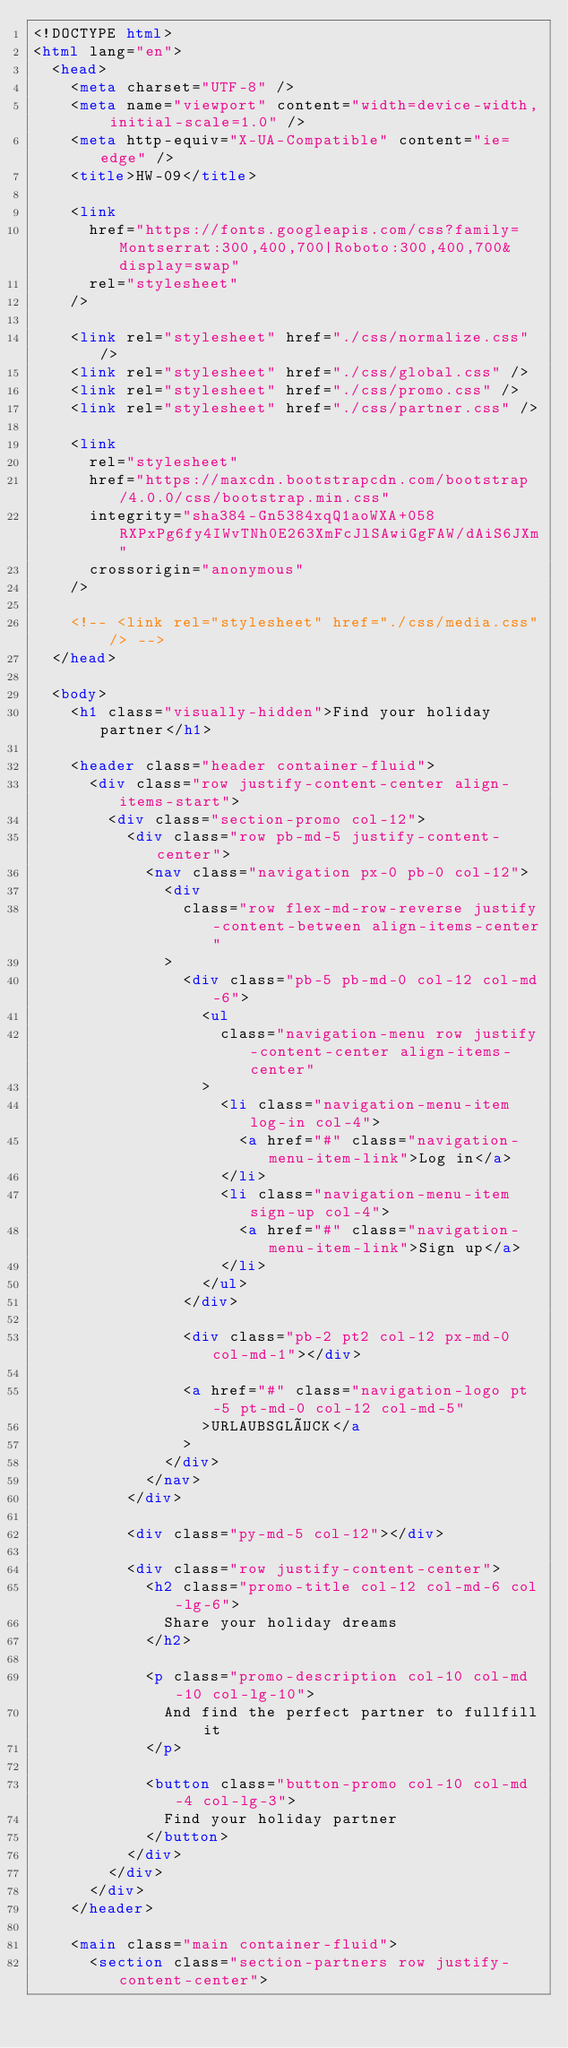Convert code to text. <code><loc_0><loc_0><loc_500><loc_500><_HTML_><!DOCTYPE html>
<html lang="en">
  <head>
    <meta charset="UTF-8" />
    <meta name="viewport" content="width=device-width, initial-scale=1.0" />
    <meta http-equiv="X-UA-Compatible" content="ie=edge" />
    <title>HW-09</title>

    <link
      href="https://fonts.googleapis.com/css?family=Montserrat:300,400,700|Roboto:300,400,700&display=swap"
      rel="stylesheet"
    />

    <link rel="stylesheet" href="./css/normalize.css" />
    <link rel="stylesheet" href="./css/global.css" />
    <link rel="stylesheet" href="./css/promo.css" />
    <link rel="stylesheet" href="./css/partner.css" />

    <link
      rel="stylesheet"
      href="https://maxcdn.bootstrapcdn.com/bootstrap/4.0.0/css/bootstrap.min.css"
      integrity="sha384-Gn5384xqQ1aoWXA+058RXPxPg6fy4IWvTNh0E263XmFcJlSAwiGgFAW/dAiS6JXm"
      crossorigin="anonymous"
    />

    <!-- <link rel="stylesheet" href="./css/media.css" /> -->
  </head>

  <body>
    <h1 class="visually-hidden">Find your holiday partner</h1>

    <header class="header container-fluid">
      <div class="row justify-content-center align-items-start">
        <div class="section-promo col-12">
          <div class="row pb-md-5 justify-content-center">
            <nav class="navigation px-0 pb-0 col-12">
              <div
                class="row flex-md-row-reverse justify-content-between align-items-center"
              >
                <div class="pb-5 pb-md-0 col-12 col-md-6">
                  <ul
                    class="navigation-menu row justify-content-center align-items-center"
                  >
                    <li class="navigation-menu-item log-in col-4">
                      <a href="#" class="navigation-menu-item-link">Log in</a>
                    </li>
                    <li class="navigation-menu-item sign-up col-4">
                      <a href="#" class="navigation-menu-item-link">Sign up</a>
                    </li>
                  </ul>
                </div>

                <div class="pb-2 pt2 col-12 px-md-0 col-md-1"></div>

                <a href="#" class="navigation-logo pt-5 pt-md-0 col-12 col-md-5"
                  >URLAUBSGLÜCK</a
                >
              </div>
            </nav>
          </div>

          <div class="py-md-5 col-12"></div>

          <div class="row justify-content-center">
            <h2 class="promo-title col-12 col-md-6 col-lg-6">
              Share your holiday dreams
            </h2>

            <p class="promo-description col-10 col-md-10 col-lg-10">
              And find the perfect partner to fullfill it
            </p>

            <button class="button-promo col-10 col-md-4 col-lg-3">
              Find your holiday partner
            </button>
          </div>
        </div>
      </div>
    </header>

    <main class="main container-fluid">
      <section class="section-partners row justify-content-center"></code> 